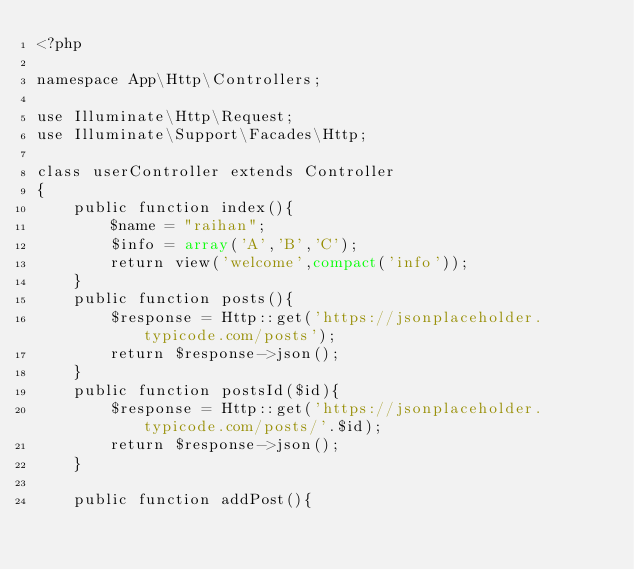Convert code to text. <code><loc_0><loc_0><loc_500><loc_500><_PHP_><?php

namespace App\Http\Controllers;

use Illuminate\Http\Request;
use Illuminate\Support\Facades\Http;

class userController extends Controller
{
    public function index(){
        $name = "raihan";
        $info = array('A','B','C');
        return view('welcome',compact('info'));
    }
    public function posts(){
        $response = Http::get('https://jsonplaceholder.typicode.com/posts');
        return $response->json();
    }
    public function postsId($id){
        $response = Http::get('https://jsonplaceholder.typicode.com/posts/'.$id);
        return $response->json();
    }

    public function addPost(){</code> 